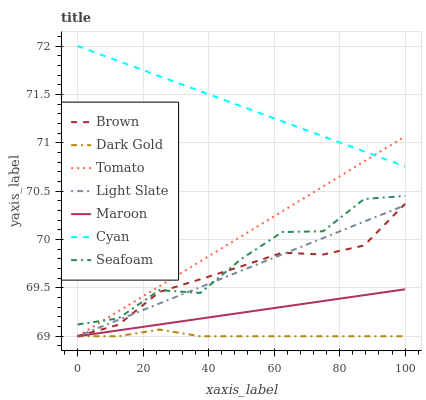Does Dark Gold have the minimum area under the curve?
Answer yes or no. Yes. Does Cyan have the maximum area under the curve?
Answer yes or no. Yes. Does Brown have the minimum area under the curve?
Answer yes or no. No. Does Brown have the maximum area under the curve?
Answer yes or no. No. Is Cyan the smoothest?
Answer yes or no. Yes. Is Seafoam the roughest?
Answer yes or no. Yes. Is Brown the smoothest?
Answer yes or no. No. Is Brown the roughest?
Answer yes or no. No. Does Tomato have the lowest value?
Answer yes or no. Yes. Does Seafoam have the lowest value?
Answer yes or no. No. Does Cyan have the highest value?
Answer yes or no. Yes. Does Brown have the highest value?
Answer yes or no. No. Is Brown less than Cyan?
Answer yes or no. Yes. Is Cyan greater than Light Slate?
Answer yes or no. Yes. Does Tomato intersect Cyan?
Answer yes or no. Yes. Is Tomato less than Cyan?
Answer yes or no. No. Is Tomato greater than Cyan?
Answer yes or no. No. Does Brown intersect Cyan?
Answer yes or no. No. 